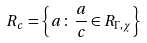<formula> <loc_0><loc_0><loc_500><loc_500>R _ { c } = \left \{ a \, \colon \, \frac { a } { c } \in R _ { \Gamma , \chi } \right \}</formula> 